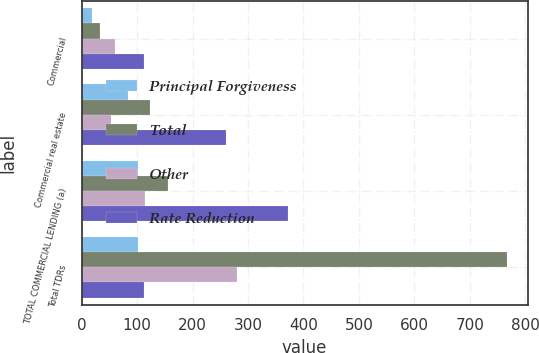<chart> <loc_0><loc_0><loc_500><loc_500><stacked_bar_chart><ecel><fcel>Commercial<fcel>Commercial real estate<fcel>TOTAL COMMERCIAL LENDING (a)<fcel>Total TDRs<nl><fcel>Principal Forgiveness<fcel>19<fcel>83<fcel>102<fcel>102<nl><fcel>Total<fcel>33<fcel>123<fcel>156<fcel>766<nl><fcel>Other<fcel>60<fcel>54<fcel>114<fcel>280<nl><fcel>Rate Reduction<fcel>112<fcel>260<fcel>372<fcel>112<nl></chart> 